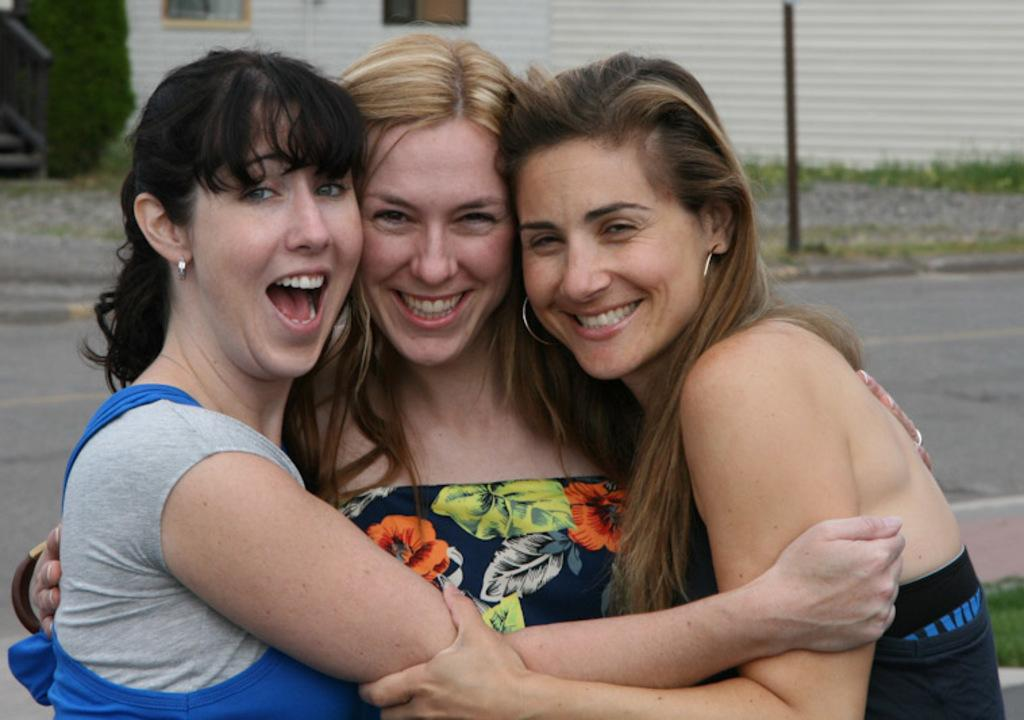How many women are in the image? There are three women in the image. What are the women doing in the image? The women are standing in the front and smiling. What can be seen in the background of the image? There is a road in the background. What word is visible in front of the road? The word "hope" is visible in front of the road. What type of fruit is hanging from the tree in the image? There is no tree or fruit present in the image. 